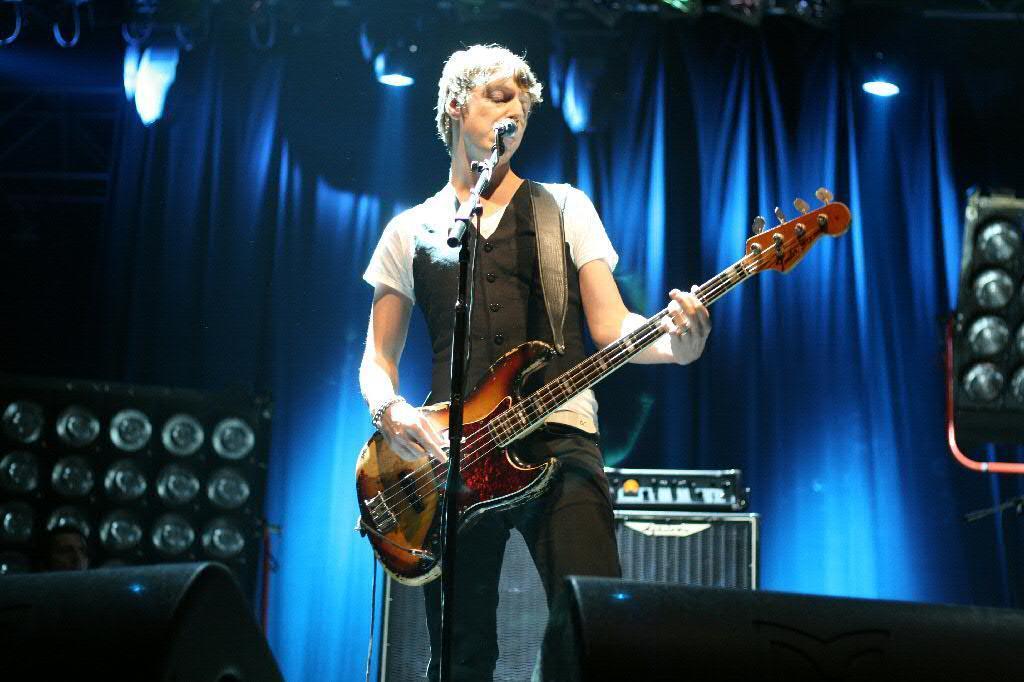How would you summarize this image in a sentence or two? In this picture we can see man holding guitar in his hand and playing it and singing on mic and aside to him we have speakers, curtains, lights. 